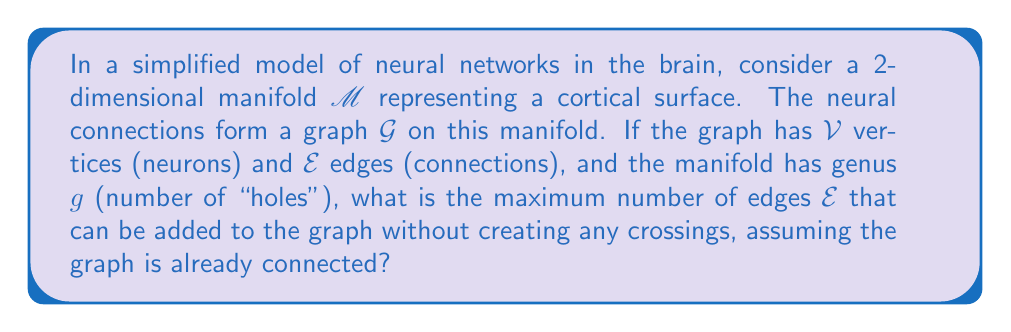Show me your answer to this math problem. To solve this problem, we'll use concepts from topological graph theory, specifically the Euler characteristic and the maximum number of edges in a planar graph.

1) First, recall the Euler characteristic formula for a graph embedded on a surface:
   $$ \chi = V - E + F $$
   where $\chi$ is the Euler characteristic, $V$ is the number of vertices, $E$ is the number of edges, and $F$ is the number of faces.

2) For a surface of genus $g$, the Euler characteristic is given by:
   $$ \chi = 2 - 2g $$

3) Combining these, we get:
   $$ 2 - 2g = V - E + F $$

4) Rearranging to solve for $F$:
   $$ F = 2 - 2g - V + E $$

5) Now, we use the fact that in a maximal planar graph (a planar graph with the maximum number of edges), every face except the exterior face is a triangle. The number of triangles is $F - 1$.

6) Each edge borders two faces (or the same face twice), so:
   $$ 2E = 3(F - 1) + k $$
   where $k$ is the number of edges on the exterior face.

7) For a graph on a surface of genus $g > 0$, the exterior face concept doesn't apply in the same way, so we can consider $k = 0$ for the maximum case.

8) Substituting and simplifying:
   $$ 2E = 3(2 - 2g - V + E - 1) $$
   $$ 2E = 6 - 6g - 3V + 3E - 3 $$
   $$ -E = 3 - 6g - 3V $$
   $$ E = 3V + 6g - 3 $$

9) This gives us the maximum number of edges for a graph embedded on a surface of genus $g$ with $V$ vertices.

For a nursing student, this model could represent how neural connections (edges) between neurons (vertices) are organized on the cortical surface (manifold), with the genus representing the complexity of the brain's folded structure.
Answer: The maximum number of edges $E$ that can be added to the graph without creating crossings is given by the formula:

$$ E = 3V + 6g - 3 $$

where $V$ is the number of vertices (neurons) and $g$ is the genus of the manifold representing the cortical surface. 